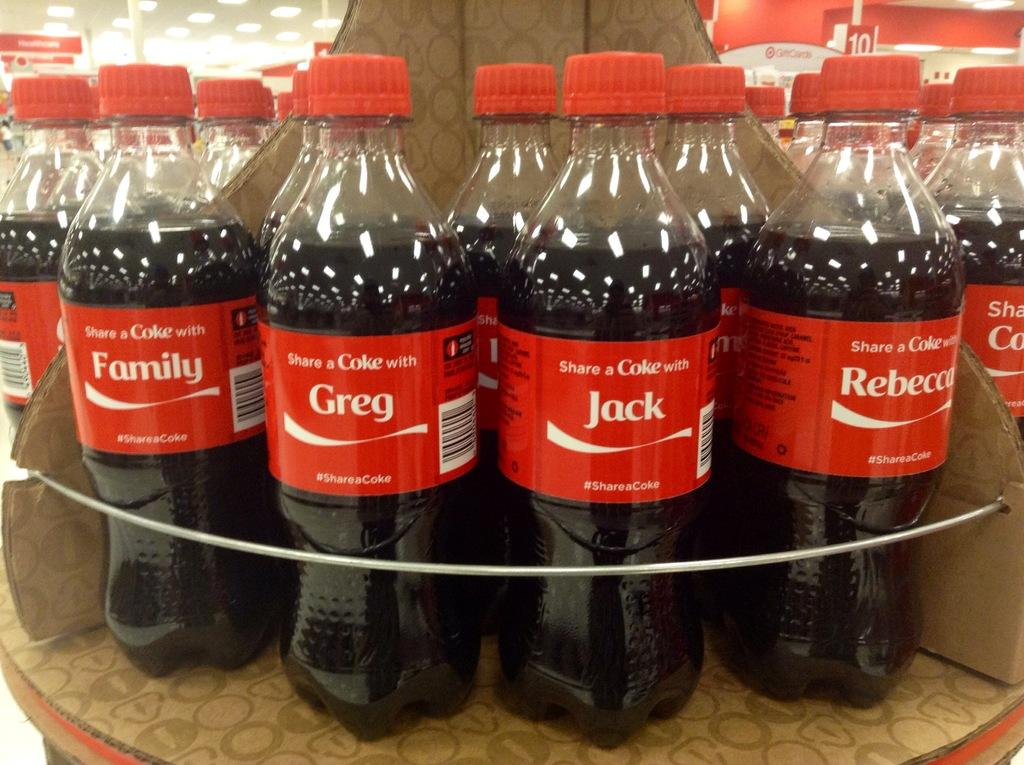<image>
Create a compact narrative representing the image presented. A Coca Cola display with bottles that all say "share a Coke with" and a person's name. 